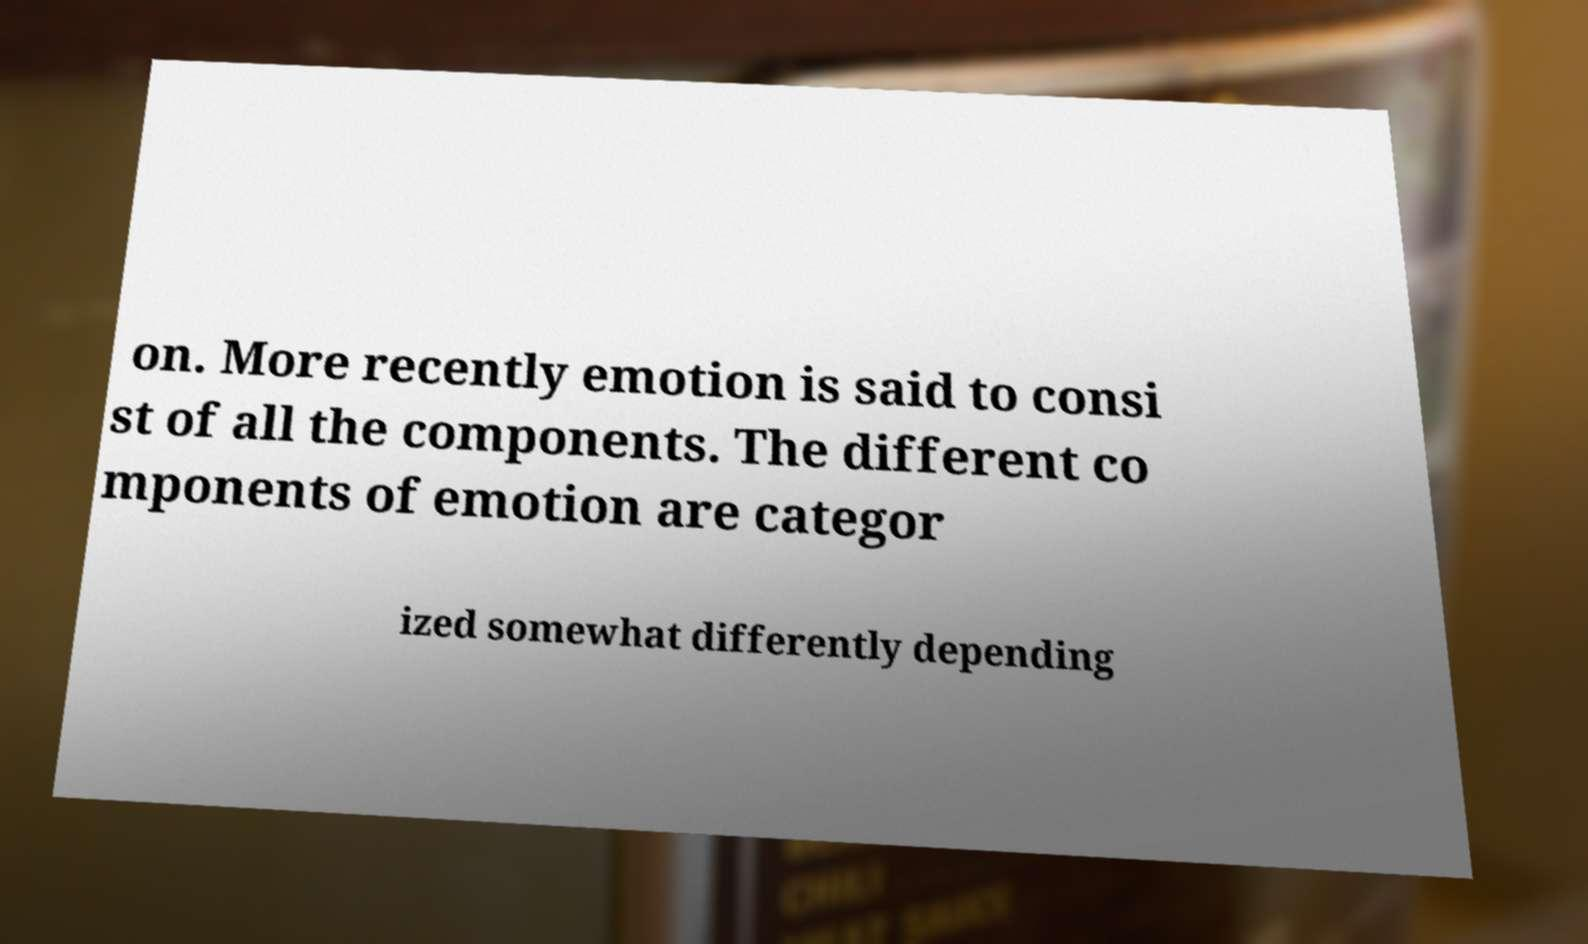Can you accurately transcribe the text from the provided image for me? on. More recently emotion is said to consi st of all the components. The different co mponents of emotion are categor ized somewhat differently depending 